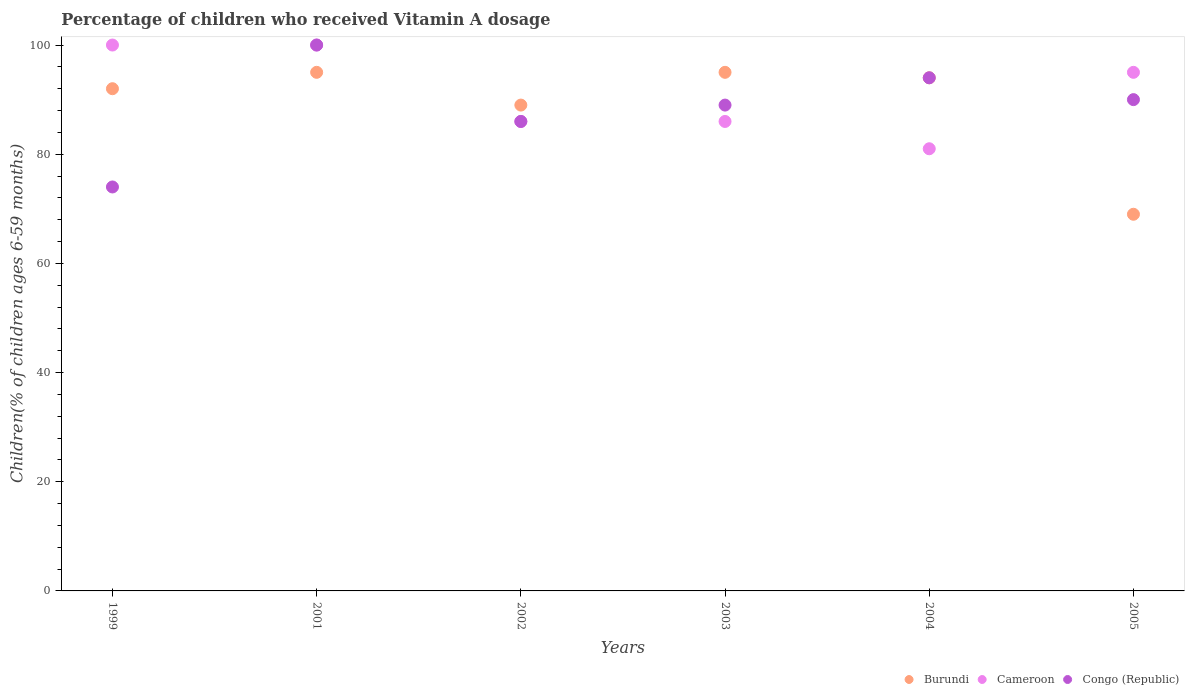How many different coloured dotlines are there?
Make the answer very short. 3. What is the percentage of children who received Vitamin A dosage in Congo (Republic) in 2005?
Give a very brief answer. 90. Across all years, what is the minimum percentage of children who received Vitamin A dosage in Burundi?
Give a very brief answer. 69. In which year was the percentage of children who received Vitamin A dosage in Congo (Republic) maximum?
Offer a terse response. 2001. In which year was the percentage of children who received Vitamin A dosage in Burundi minimum?
Offer a very short reply. 2005. What is the total percentage of children who received Vitamin A dosage in Congo (Republic) in the graph?
Provide a succinct answer. 533. What is the difference between the percentage of children who received Vitamin A dosage in Burundi in 1999 and the percentage of children who received Vitamin A dosage in Congo (Republic) in 2005?
Give a very brief answer. 2. What is the average percentage of children who received Vitamin A dosage in Cameroon per year?
Your answer should be very brief. 91.33. In the year 2004, what is the difference between the percentage of children who received Vitamin A dosage in Cameroon and percentage of children who received Vitamin A dosage in Burundi?
Provide a short and direct response. -13. In how many years, is the percentage of children who received Vitamin A dosage in Congo (Republic) greater than 88 %?
Give a very brief answer. 4. What is the ratio of the percentage of children who received Vitamin A dosage in Burundi in 2002 to that in 2005?
Your answer should be very brief. 1.29. Is the difference between the percentage of children who received Vitamin A dosage in Cameroon in 2001 and 2005 greater than the difference between the percentage of children who received Vitamin A dosage in Burundi in 2001 and 2005?
Your response must be concise. No. What is the difference between the highest and the lowest percentage of children who received Vitamin A dosage in Burundi?
Give a very brief answer. 26. In how many years, is the percentage of children who received Vitamin A dosage in Congo (Republic) greater than the average percentage of children who received Vitamin A dosage in Congo (Republic) taken over all years?
Make the answer very short. 4. Is the sum of the percentage of children who received Vitamin A dosage in Cameroon in 2001 and 2005 greater than the maximum percentage of children who received Vitamin A dosage in Congo (Republic) across all years?
Give a very brief answer. Yes. Is it the case that in every year, the sum of the percentage of children who received Vitamin A dosage in Cameroon and percentage of children who received Vitamin A dosage in Congo (Republic)  is greater than the percentage of children who received Vitamin A dosage in Burundi?
Offer a very short reply. Yes. Is the percentage of children who received Vitamin A dosage in Congo (Republic) strictly greater than the percentage of children who received Vitamin A dosage in Burundi over the years?
Ensure brevity in your answer.  No. Is the percentage of children who received Vitamin A dosage in Burundi strictly less than the percentage of children who received Vitamin A dosage in Cameroon over the years?
Your answer should be compact. No. How many dotlines are there?
Your response must be concise. 3. How many years are there in the graph?
Your response must be concise. 6. What is the difference between two consecutive major ticks on the Y-axis?
Your response must be concise. 20. Does the graph contain grids?
Keep it short and to the point. No. How many legend labels are there?
Your response must be concise. 3. What is the title of the graph?
Your response must be concise. Percentage of children who received Vitamin A dosage. Does "New Zealand" appear as one of the legend labels in the graph?
Offer a very short reply. No. What is the label or title of the Y-axis?
Offer a terse response. Children(% of children ages 6-59 months). What is the Children(% of children ages 6-59 months) in Burundi in 1999?
Your answer should be compact. 92. What is the Children(% of children ages 6-59 months) in Cameroon in 1999?
Your response must be concise. 100. What is the Children(% of children ages 6-59 months) of Cameroon in 2001?
Your answer should be compact. 100. What is the Children(% of children ages 6-59 months) of Burundi in 2002?
Your answer should be very brief. 89. What is the Children(% of children ages 6-59 months) of Cameroon in 2002?
Your response must be concise. 86. What is the Children(% of children ages 6-59 months) of Burundi in 2003?
Offer a terse response. 95. What is the Children(% of children ages 6-59 months) of Cameroon in 2003?
Keep it short and to the point. 86. What is the Children(% of children ages 6-59 months) of Congo (Republic) in 2003?
Provide a succinct answer. 89. What is the Children(% of children ages 6-59 months) of Burundi in 2004?
Your response must be concise. 94. What is the Children(% of children ages 6-59 months) in Cameroon in 2004?
Provide a short and direct response. 81. What is the Children(% of children ages 6-59 months) in Congo (Republic) in 2004?
Your answer should be very brief. 94. What is the Children(% of children ages 6-59 months) of Burundi in 2005?
Your answer should be very brief. 69. What is the Children(% of children ages 6-59 months) in Cameroon in 2005?
Offer a terse response. 95. Across all years, what is the maximum Children(% of children ages 6-59 months) of Cameroon?
Ensure brevity in your answer.  100. Across all years, what is the minimum Children(% of children ages 6-59 months) of Cameroon?
Your answer should be very brief. 81. What is the total Children(% of children ages 6-59 months) of Burundi in the graph?
Make the answer very short. 534. What is the total Children(% of children ages 6-59 months) of Cameroon in the graph?
Your answer should be very brief. 548. What is the total Children(% of children ages 6-59 months) of Congo (Republic) in the graph?
Provide a succinct answer. 533. What is the difference between the Children(% of children ages 6-59 months) of Burundi in 1999 and that in 2001?
Provide a short and direct response. -3. What is the difference between the Children(% of children ages 6-59 months) in Cameroon in 1999 and that in 2001?
Provide a succinct answer. 0. What is the difference between the Children(% of children ages 6-59 months) of Congo (Republic) in 1999 and that in 2001?
Offer a very short reply. -26. What is the difference between the Children(% of children ages 6-59 months) in Congo (Republic) in 1999 and that in 2002?
Ensure brevity in your answer.  -12. What is the difference between the Children(% of children ages 6-59 months) in Burundi in 1999 and that in 2003?
Offer a very short reply. -3. What is the difference between the Children(% of children ages 6-59 months) in Cameroon in 1999 and that in 2003?
Offer a very short reply. 14. What is the difference between the Children(% of children ages 6-59 months) of Cameroon in 1999 and that in 2004?
Your response must be concise. 19. What is the difference between the Children(% of children ages 6-59 months) in Congo (Republic) in 1999 and that in 2004?
Your answer should be very brief. -20. What is the difference between the Children(% of children ages 6-59 months) of Burundi in 1999 and that in 2005?
Your response must be concise. 23. What is the difference between the Children(% of children ages 6-59 months) in Cameroon in 1999 and that in 2005?
Offer a very short reply. 5. What is the difference between the Children(% of children ages 6-59 months) of Congo (Republic) in 1999 and that in 2005?
Ensure brevity in your answer.  -16. What is the difference between the Children(% of children ages 6-59 months) in Cameroon in 2001 and that in 2002?
Your answer should be compact. 14. What is the difference between the Children(% of children ages 6-59 months) of Burundi in 2001 and that in 2003?
Your response must be concise. 0. What is the difference between the Children(% of children ages 6-59 months) of Cameroon in 2001 and that in 2003?
Keep it short and to the point. 14. What is the difference between the Children(% of children ages 6-59 months) in Congo (Republic) in 2001 and that in 2003?
Give a very brief answer. 11. What is the difference between the Children(% of children ages 6-59 months) in Burundi in 2001 and that in 2005?
Offer a very short reply. 26. What is the difference between the Children(% of children ages 6-59 months) of Congo (Republic) in 2001 and that in 2005?
Give a very brief answer. 10. What is the difference between the Children(% of children ages 6-59 months) of Cameroon in 2002 and that in 2003?
Your answer should be very brief. 0. What is the difference between the Children(% of children ages 6-59 months) in Congo (Republic) in 2002 and that in 2003?
Your answer should be compact. -3. What is the difference between the Children(% of children ages 6-59 months) in Cameroon in 2002 and that in 2004?
Your response must be concise. 5. What is the difference between the Children(% of children ages 6-59 months) in Congo (Republic) in 2002 and that in 2004?
Your answer should be compact. -8. What is the difference between the Children(% of children ages 6-59 months) of Cameroon in 2003 and that in 2004?
Your answer should be compact. 5. What is the difference between the Children(% of children ages 6-59 months) in Burundi in 2003 and that in 2005?
Provide a succinct answer. 26. What is the difference between the Children(% of children ages 6-59 months) of Congo (Republic) in 2004 and that in 2005?
Offer a terse response. 4. What is the difference between the Children(% of children ages 6-59 months) of Cameroon in 1999 and the Children(% of children ages 6-59 months) of Congo (Republic) in 2001?
Your answer should be compact. 0. What is the difference between the Children(% of children ages 6-59 months) of Burundi in 1999 and the Children(% of children ages 6-59 months) of Cameroon in 2002?
Provide a succinct answer. 6. What is the difference between the Children(% of children ages 6-59 months) of Cameroon in 1999 and the Children(% of children ages 6-59 months) of Congo (Republic) in 2002?
Ensure brevity in your answer.  14. What is the difference between the Children(% of children ages 6-59 months) of Burundi in 1999 and the Children(% of children ages 6-59 months) of Cameroon in 2003?
Ensure brevity in your answer.  6. What is the difference between the Children(% of children ages 6-59 months) of Cameroon in 1999 and the Children(% of children ages 6-59 months) of Congo (Republic) in 2003?
Offer a very short reply. 11. What is the difference between the Children(% of children ages 6-59 months) of Burundi in 1999 and the Children(% of children ages 6-59 months) of Cameroon in 2004?
Your answer should be very brief. 11. What is the difference between the Children(% of children ages 6-59 months) of Burundi in 1999 and the Children(% of children ages 6-59 months) of Congo (Republic) in 2004?
Provide a succinct answer. -2. What is the difference between the Children(% of children ages 6-59 months) of Burundi in 1999 and the Children(% of children ages 6-59 months) of Cameroon in 2005?
Make the answer very short. -3. What is the difference between the Children(% of children ages 6-59 months) in Burundi in 1999 and the Children(% of children ages 6-59 months) in Congo (Republic) in 2005?
Your response must be concise. 2. What is the difference between the Children(% of children ages 6-59 months) in Cameroon in 1999 and the Children(% of children ages 6-59 months) in Congo (Republic) in 2005?
Your response must be concise. 10. What is the difference between the Children(% of children ages 6-59 months) of Burundi in 2001 and the Children(% of children ages 6-59 months) of Cameroon in 2002?
Give a very brief answer. 9. What is the difference between the Children(% of children ages 6-59 months) of Burundi in 2001 and the Children(% of children ages 6-59 months) of Congo (Republic) in 2002?
Provide a succinct answer. 9. What is the difference between the Children(% of children ages 6-59 months) in Cameroon in 2001 and the Children(% of children ages 6-59 months) in Congo (Republic) in 2002?
Your answer should be very brief. 14. What is the difference between the Children(% of children ages 6-59 months) of Burundi in 2001 and the Children(% of children ages 6-59 months) of Cameroon in 2003?
Your response must be concise. 9. What is the difference between the Children(% of children ages 6-59 months) of Burundi in 2001 and the Children(% of children ages 6-59 months) of Cameroon in 2004?
Give a very brief answer. 14. What is the difference between the Children(% of children ages 6-59 months) of Burundi in 2001 and the Children(% of children ages 6-59 months) of Cameroon in 2005?
Make the answer very short. 0. What is the difference between the Children(% of children ages 6-59 months) of Burundi in 2002 and the Children(% of children ages 6-59 months) of Cameroon in 2003?
Ensure brevity in your answer.  3. What is the difference between the Children(% of children ages 6-59 months) of Burundi in 2002 and the Children(% of children ages 6-59 months) of Congo (Republic) in 2003?
Your answer should be very brief. 0. What is the difference between the Children(% of children ages 6-59 months) of Cameroon in 2002 and the Children(% of children ages 6-59 months) of Congo (Republic) in 2003?
Your answer should be very brief. -3. What is the difference between the Children(% of children ages 6-59 months) in Burundi in 2002 and the Children(% of children ages 6-59 months) in Cameroon in 2004?
Offer a terse response. 8. What is the difference between the Children(% of children ages 6-59 months) of Cameroon in 2002 and the Children(% of children ages 6-59 months) of Congo (Republic) in 2004?
Keep it short and to the point. -8. What is the difference between the Children(% of children ages 6-59 months) in Burundi in 2002 and the Children(% of children ages 6-59 months) in Cameroon in 2005?
Offer a very short reply. -6. What is the difference between the Children(% of children ages 6-59 months) in Burundi in 2003 and the Children(% of children ages 6-59 months) in Cameroon in 2005?
Offer a very short reply. 0. What is the difference between the Children(% of children ages 6-59 months) in Burundi in 2003 and the Children(% of children ages 6-59 months) in Congo (Republic) in 2005?
Offer a very short reply. 5. What is the difference between the Children(% of children ages 6-59 months) in Cameroon in 2003 and the Children(% of children ages 6-59 months) in Congo (Republic) in 2005?
Offer a very short reply. -4. What is the difference between the Children(% of children ages 6-59 months) of Burundi in 2004 and the Children(% of children ages 6-59 months) of Cameroon in 2005?
Ensure brevity in your answer.  -1. What is the average Children(% of children ages 6-59 months) in Burundi per year?
Offer a terse response. 89. What is the average Children(% of children ages 6-59 months) in Cameroon per year?
Offer a terse response. 91.33. What is the average Children(% of children ages 6-59 months) of Congo (Republic) per year?
Your answer should be very brief. 88.83. In the year 2001, what is the difference between the Children(% of children ages 6-59 months) in Burundi and Children(% of children ages 6-59 months) in Cameroon?
Keep it short and to the point. -5. In the year 2003, what is the difference between the Children(% of children ages 6-59 months) of Burundi and Children(% of children ages 6-59 months) of Congo (Republic)?
Give a very brief answer. 6. In the year 2003, what is the difference between the Children(% of children ages 6-59 months) of Cameroon and Children(% of children ages 6-59 months) of Congo (Republic)?
Keep it short and to the point. -3. In the year 2004, what is the difference between the Children(% of children ages 6-59 months) in Burundi and Children(% of children ages 6-59 months) in Cameroon?
Offer a terse response. 13. In the year 2004, what is the difference between the Children(% of children ages 6-59 months) in Burundi and Children(% of children ages 6-59 months) in Congo (Republic)?
Make the answer very short. 0. In the year 2004, what is the difference between the Children(% of children ages 6-59 months) in Cameroon and Children(% of children ages 6-59 months) in Congo (Republic)?
Give a very brief answer. -13. In the year 2005, what is the difference between the Children(% of children ages 6-59 months) of Burundi and Children(% of children ages 6-59 months) of Cameroon?
Ensure brevity in your answer.  -26. In the year 2005, what is the difference between the Children(% of children ages 6-59 months) of Burundi and Children(% of children ages 6-59 months) of Congo (Republic)?
Your answer should be very brief. -21. In the year 2005, what is the difference between the Children(% of children ages 6-59 months) in Cameroon and Children(% of children ages 6-59 months) in Congo (Republic)?
Keep it short and to the point. 5. What is the ratio of the Children(% of children ages 6-59 months) of Burundi in 1999 to that in 2001?
Keep it short and to the point. 0.97. What is the ratio of the Children(% of children ages 6-59 months) of Cameroon in 1999 to that in 2001?
Your answer should be compact. 1. What is the ratio of the Children(% of children ages 6-59 months) in Congo (Republic) in 1999 to that in 2001?
Provide a succinct answer. 0.74. What is the ratio of the Children(% of children ages 6-59 months) in Burundi in 1999 to that in 2002?
Offer a terse response. 1.03. What is the ratio of the Children(% of children ages 6-59 months) of Cameroon in 1999 to that in 2002?
Your response must be concise. 1.16. What is the ratio of the Children(% of children ages 6-59 months) in Congo (Republic) in 1999 to that in 2002?
Make the answer very short. 0.86. What is the ratio of the Children(% of children ages 6-59 months) of Burundi in 1999 to that in 2003?
Make the answer very short. 0.97. What is the ratio of the Children(% of children ages 6-59 months) in Cameroon in 1999 to that in 2003?
Give a very brief answer. 1.16. What is the ratio of the Children(% of children ages 6-59 months) in Congo (Republic) in 1999 to that in 2003?
Your answer should be very brief. 0.83. What is the ratio of the Children(% of children ages 6-59 months) of Burundi in 1999 to that in 2004?
Offer a terse response. 0.98. What is the ratio of the Children(% of children ages 6-59 months) in Cameroon in 1999 to that in 2004?
Your response must be concise. 1.23. What is the ratio of the Children(% of children ages 6-59 months) in Congo (Republic) in 1999 to that in 2004?
Ensure brevity in your answer.  0.79. What is the ratio of the Children(% of children ages 6-59 months) in Cameroon in 1999 to that in 2005?
Your answer should be compact. 1.05. What is the ratio of the Children(% of children ages 6-59 months) of Congo (Republic) in 1999 to that in 2005?
Provide a short and direct response. 0.82. What is the ratio of the Children(% of children ages 6-59 months) in Burundi in 2001 to that in 2002?
Your answer should be compact. 1.07. What is the ratio of the Children(% of children ages 6-59 months) of Cameroon in 2001 to that in 2002?
Provide a succinct answer. 1.16. What is the ratio of the Children(% of children ages 6-59 months) in Congo (Republic) in 2001 to that in 2002?
Ensure brevity in your answer.  1.16. What is the ratio of the Children(% of children ages 6-59 months) in Burundi in 2001 to that in 2003?
Provide a succinct answer. 1. What is the ratio of the Children(% of children ages 6-59 months) in Cameroon in 2001 to that in 2003?
Keep it short and to the point. 1.16. What is the ratio of the Children(% of children ages 6-59 months) in Congo (Republic) in 2001 to that in 2003?
Your response must be concise. 1.12. What is the ratio of the Children(% of children ages 6-59 months) in Burundi in 2001 to that in 2004?
Your response must be concise. 1.01. What is the ratio of the Children(% of children ages 6-59 months) of Cameroon in 2001 to that in 2004?
Your answer should be very brief. 1.23. What is the ratio of the Children(% of children ages 6-59 months) in Congo (Republic) in 2001 to that in 2004?
Offer a terse response. 1.06. What is the ratio of the Children(% of children ages 6-59 months) of Burundi in 2001 to that in 2005?
Make the answer very short. 1.38. What is the ratio of the Children(% of children ages 6-59 months) of Cameroon in 2001 to that in 2005?
Offer a very short reply. 1.05. What is the ratio of the Children(% of children ages 6-59 months) in Burundi in 2002 to that in 2003?
Offer a very short reply. 0.94. What is the ratio of the Children(% of children ages 6-59 months) in Congo (Republic) in 2002 to that in 2003?
Provide a succinct answer. 0.97. What is the ratio of the Children(% of children ages 6-59 months) in Burundi in 2002 to that in 2004?
Offer a terse response. 0.95. What is the ratio of the Children(% of children ages 6-59 months) of Cameroon in 2002 to that in 2004?
Give a very brief answer. 1.06. What is the ratio of the Children(% of children ages 6-59 months) in Congo (Republic) in 2002 to that in 2004?
Give a very brief answer. 0.91. What is the ratio of the Children(% of children ages 6-59 months) of Burundi in 2002 to that in 2005?
Offer a terse response. 1.29. What is the ratio of the Children(% of children ages 6-59 months) of Cameroon in 2002 to that in 2005?
Offer a terse response. 0.91. What is the ratio of the Children(% of children ages 6-59 months) of Congo (Republic) in 2002 to that in 2005?
Offer a very short reply. 0.96. What is the ratio of the Children(% of children ages 6-59 months) of Burundi in 2003 to that in 2004?
Your response must be concise. 1.01. What is the ratio of the Children(% of children ages 6-59 months) in Cameroon in 2003 to that in 2004?
Your answer should be very brief. 1.06. What is the ratio of the Children(% of children ages 6-59 months) of Congo (Republic) in 2003 to that in 2004?
Give a very brief answer. 0.95. What is the ratio of the Children(% of children ages 6-59 months) in Burundi in 2003 to that in 2005?
Give a very brief answer. 1.38. What is the ratio of the Children(% of children ages 6-59 months) of Cameroon in 2003 to that in 2005?
Keep it short and to the point. 0.91. What is the ratio of the Children(% of children ages 6-59 months) of Congo (Republic) in 2003 to that in 2005?
Keep it short and to the point. 0.99. What is the ratio of the Children(% of children ages 6-59 months) in Burundi in 2004 to that in 2005?
Ensure brevity in your answer.  1.36. What is the ratio of the Children(% of children ages 6-59 months) in Cameroon in 2004 to that in 2005?
Offer a terse response. 0.85. What is the ratio of the Children(% of children ages 6-59 months) in Congo (Republic) in 2004 to that in 2005?
Offer a very short reply. 1.04. What is the difference between the highest and the second highest Children(% of children ages 6-59 months) of Burundi?
Your answer should be very brief. 0. What is the difference between the highest and the lowest Children(% of children ages 6-59 months) in Burundi?
Your response must be concise. 26. What is the difference between the highest and the lowest Children(% of children ages 6-59 months) of Cameroon?
Provide a succinct answer. 19. 